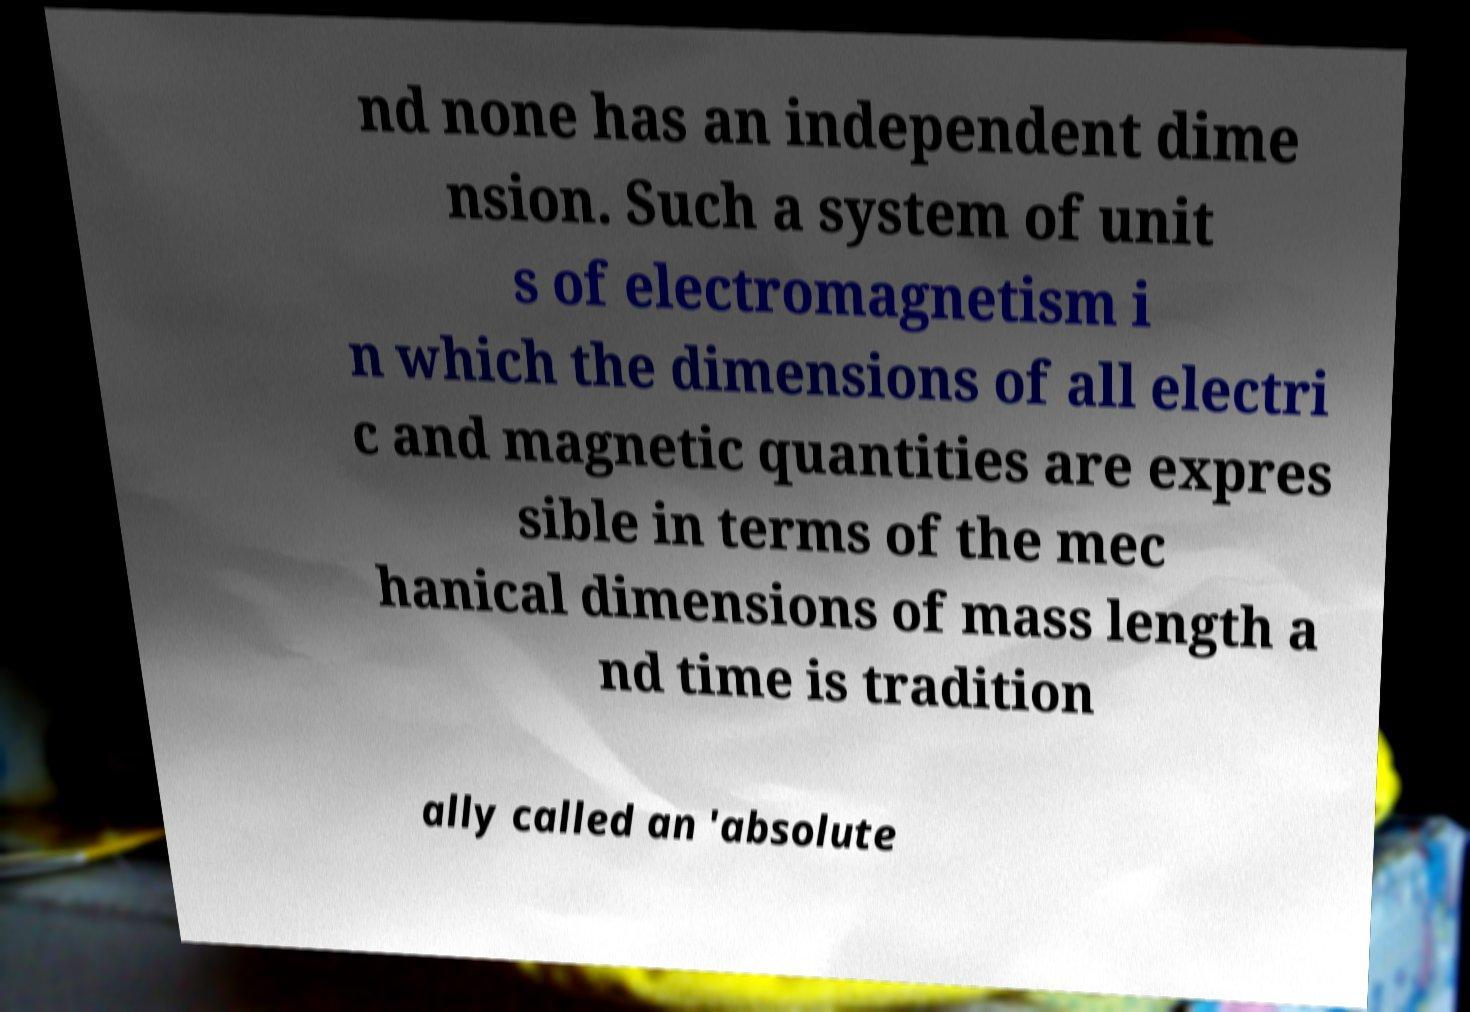Can you read and provide the text displayed in the image?This photo seems to have some interesting text. Can you extract and type it out for me? nd none has an independent dime nsion. Such a system of unit s of electromagnetism i n which the dimensions of all electri c and magnetic quantities are expres sible in terms of the mec hanical dimensions of mass length a nd time is tradition ally called an 'absolute 